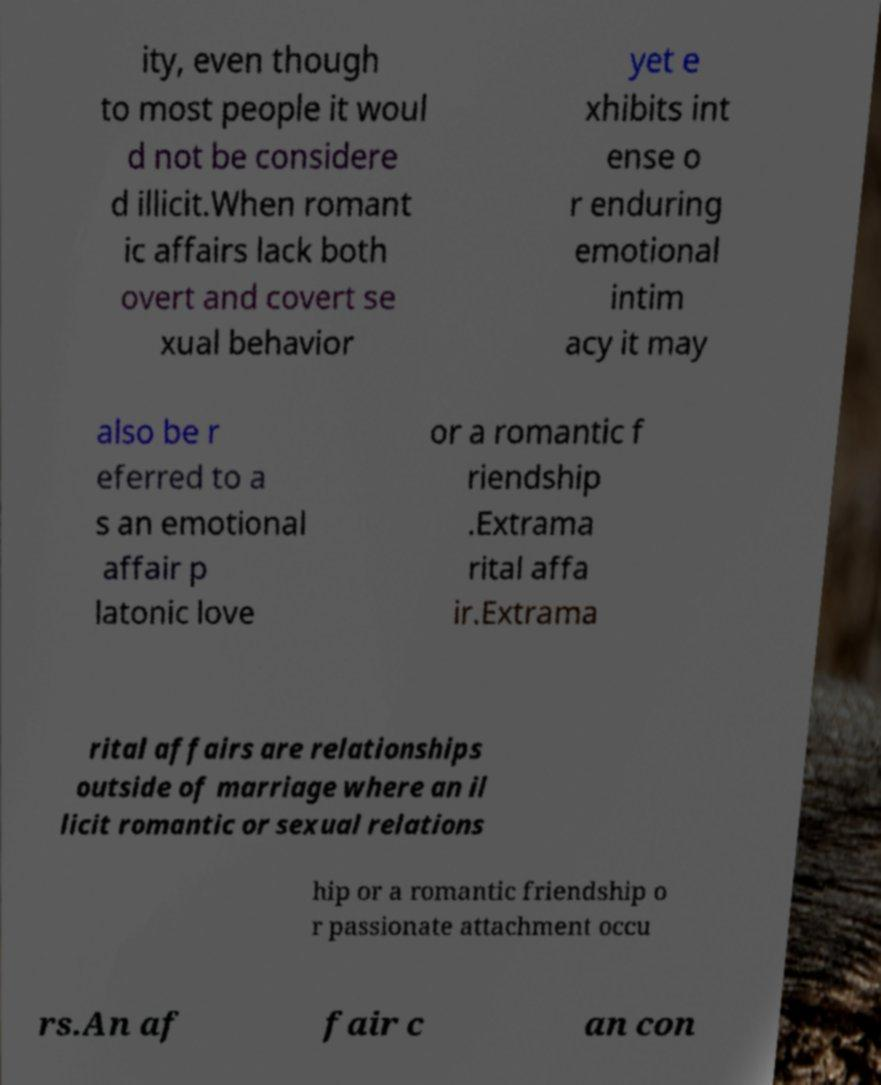Can you read and provide the text displayed in the image?This photo seems to have some interesting text. Can you extract and type it out for me? ity, even though to most people it woul d not be considere d illicit.When romant ic affairs lack both overt and covert se xual behavior yet e xhibits int ense o r enduring emotional intim acy it may also be r eferred to a s an emotional affair p latonic love or a romantic f riendship .Extrama rital affa ir.Extrama rital affairs are relationships outside of marriage where an il licit romantic or sexual relations hip or a romantic friendship o r passionate attachment occu rs.An af fair c an con 